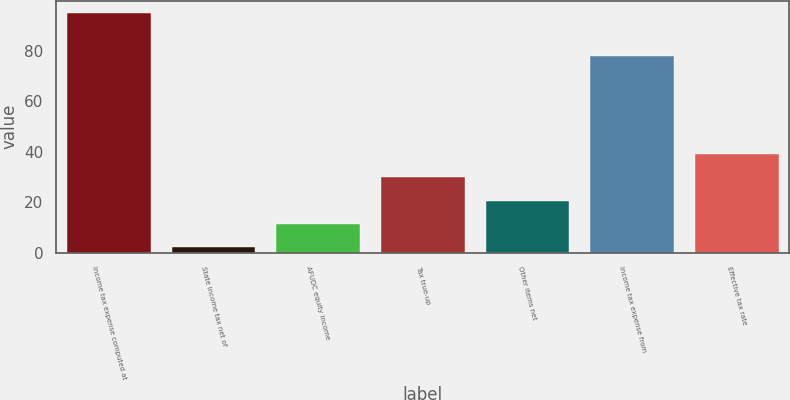Convert chart to OTSL. <chart><loc_0><loc_0><loc_500><loc_500><bar_chart><fcel>Income tax expense computed at<fcel>State income tax net of<fcel>AFUDC equity income<fcel>Tax true-up<fcel>Other items net<fcel>Income tax expense from<fcel>Effective tax rate<nl><fcel>95<fcel>2<fcel>11.3<fcel>29.9<fcel>20.6<fcel>78<fcel>39.2<nl></chart> 